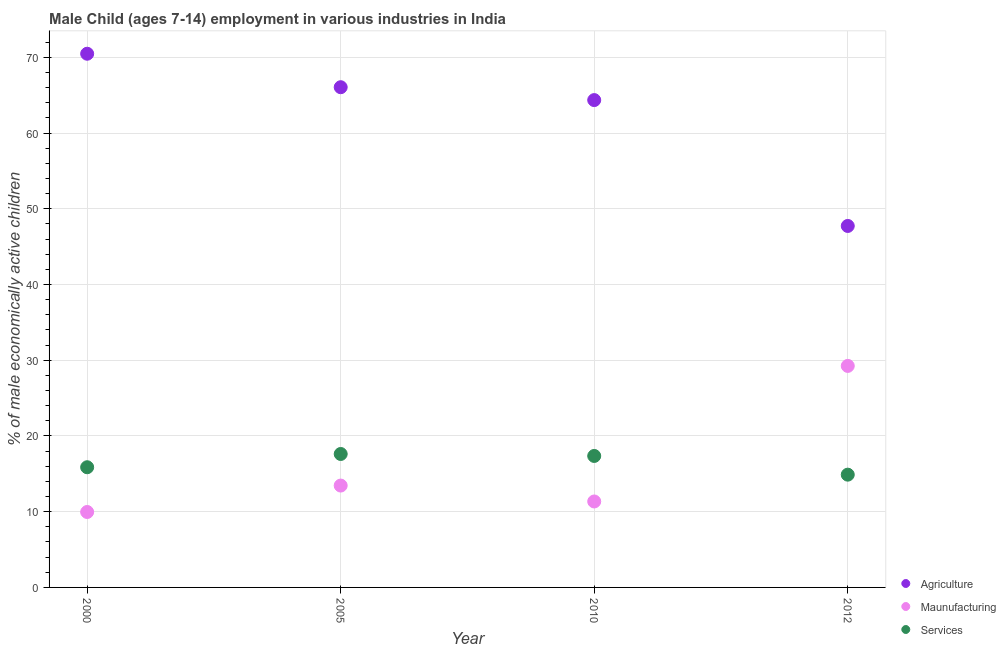How many different coloured dotlines are there?
Provide a succinct answer. 3. What is the percentage of economically active children in manufacturing in 2012?
Offer a very short reply. 29.25. Across all years, what is the maximum percentage of economically active children in services?
Keep it short and to the point. 17.62. Across all years, what is the minimum percentage of economically active children in services?
Offer a terse response. 14.89. What is the total percentage of economically active children in agriculture in the graph?
Make the answer very short. 248.6. What is the difference between the percentage of economically active children in services in 2010 and that in 2012?
Give a very brief answer. 2.47. What is the difference between the percentage of economically active children in agriculture in 2010 and the percentage of economically active children in services in 2000?
Give a very brief answer. 48.48. What is the average percentage of economically active children in manufacturing per year?
Offer a very short reply. 16. In the year 2012, what is the difference between the percentage of economically active children in services and percentage of economically active children in manufacturing?
Your answer should be compact. -14.36. In how many years, is the percentage of economically active children in services greater than 22 %?
Your response must be concise. 0. What is the ratio of the percentage of economically active children in services in 2000 to that in 2010?
Your response must be concise. 0.91. Is the percentage of economically active children in agriculture in 2005 less than that in 2012?
Your response must be concise. No. What is the difference between the highest and the second highest percentage of economically active children in services?
Offer a terse response. 0.26. What is the difference between the highest and the lowest percentage of economically active children in agriculture?
Keep it short and to the point. 22.74. In how many years, is the percentage of economically active children in services greater than the average percentage of economically active children in services taken over all years?
Keep it short and to the point. 2. Is it the case that in every year, the sum of the percentage of economically active children in agriculture and percentage of economically active children in manufacturing is greater than the percentage of economically active children in services?
Your answer should be compact. Yes. Is the percentage of economically active children in services strictly greater than the percentage of economically active children in agriculture over the years?
Provide a short and direct response. No. How many dotlines are there?
Give a very brief answer. 3. How many years are there in the graph?
Make the answer very short. 4. Are the values on the major ticks of Y-axis written in scientific E-notation?
Offer a terse response. No. Does the graph contain grids?
Your response must be concise. Yes. Where does the legend appear in the graph?
Offer a terse response. Bottom right. How many legend labels are there?
Offer a very short reply. 3. How are the legend labels stacked?
Your answer should be very brief. Vertical. What is the title of the graph?
Give a very brief answer. Male Child (ages 7-14) employment in various industries in India. Does "Taxes on income" appear as one of the legend labels in the graph?
Your response must be concise. No. What is the label or title of the Y-axis?
Your answer should be compact. % of male economically active children. What is the % of male economically active children in Agriculture in 2000?
Give a very brief answer. 70.47. What is the % of male economically active children in Maunufacturing in 2000?
Provide a short and direct response. 9.96. What is the % of male economically active children of Services in 2000?
Your answer should be compact. 15.87. What is the % of male economically active children in Agriculture in 2005?
Your response must be concise. 66.05. What is the % of male economically active children in Maunufacturing in 2005?
Your response must be concise. 13.45. What is the % of male economically active children of Services in 2005?
Your answer should be very brief. 17.62. What is the % of male economically active children of Agriculture in 2010?
Your response must be concise. 64.35. What is the % of male economically active children of Maunufacturing in 2010?
Give a very brief answer. 11.35. What is the % of male economically active children in Services in 2010?
Offer a terse response. 17.36. What is the % of male economically active children in Agriculture in 2012?
Offer a terse response. 47.73. What is the % of male economically active children in Maunufacturing in 2012?
Provide a succinct answer. 29.25. What is the % of male economically active children of Services in 2012?
Your response must be concise. 14.89. Across all years, what is the maximum % of male economically active children of Agriculture?
Offer a very short reply. 70.47. Across all years, what is the maximum % of male economically active children of Maunufacturing?
Offer a very short reply. 29.25. Across all years, what is the maximum % of male economically active children in Services?
Provide a short and direct response. 17.62. Across all years, what is the minimum % of male economically active children of Agriculture?
Give a very brief answer. 47.73. Across all years, what is the minimum % of male economically active children of Maunufacturing?
Give a very brief answer. 9.96. Across all years, what is the minimum % of male economically active children of Services?
Make the answer very short. 14.89. What is the total % of male economically active children of Agriculture in the graph?
Offer a very short reply. 248.6. What is the total % of male economically active children in Maunufacturing in the graph?
Your answer should be very brief. 64.01. What is the total % of male economically active children of Services in the graph?
Your answer should be very brief. 65.74. What is the difference between the % of male economically active children of Agriculture in 2000 and that in 2005?
Your response must be concise. 4.42. What is the difference between the % of male economically active children in Maunufacturing in 2000 and that in 2005?
Your response must be concise. -3.49. What is the difference between the % of male economically active children of Services in 2000 and that in 2005?
Make the answer very short. -1.75. What is the difference between the % of male economically active children in Agriculture in 2000 and that in 2010?
Your answer should be very brief. 6.12. What is the difference between the % of male economically active children in Maunufacturing in 2000 and that in 2010?
Your response must be concise. -1.39. What is the difference between the % of male economically active children in Services in 2000 and that in 2010?
Provide a succinct answer. -1.49. What is the difference between the % of male economically active children of Agriculture in 2000 and that in 2012?
Your answer should be compact. 22.74. What is the difference between the % of male economically active children of Maunufacturing in 2000 and that in 2012?
Provide a short and direct response. -19.29. What is the difference between the % of male economically active children in Agriculture in 2005 and that in 2010?
Your answer should be very brief. 1.7. What is the difference between the % of male economically active children in Services in 2005 and that in 2010?
Make the answer very short. 0.26. What is the difference between the % of male economically active children of Agriculture in 2005 and that in 2012?
Your response must be concise. 18.32. What is the difference between the % of male economically active children of Maunufacturing in 2005 and that in 2012?
Offer a very short reply. -15.8. What is the difference between the % of male economically active children of Services in 2005 and that in 2012?
Provide a succinct answer. 2.73. What is the difference between the % of male economically active children in Agriculture in 2010 and that in 2012?
Ensure brevity in your answer.  16.62. What is the difference between the % of male economically active children of Maunufacturing in 2010 and that in 2012?
Give a very brief answer. -17.9. What is the difference between the % of male economically active children of Services in 2010 and that in 2012?
Your answer should be very brief. 2.47. What is the difference between the % of male economically active children in Agriculture in 2000 and the % of male economically active children in Maunufacturing in 2005?
Offer a terse response. 57.02. What is the difference between the % of male economically active children in Agriculture in 2000 and the % of male economically active children in Services in 2005?
Keep it short and to the point. 52.85. What is the difference between the % of male economically active children of Maunufacturing in 2000 and the % of male economically active children of Services in 2005?
Make the answer very short. -7.66. What is the difference between the % of male economically active children in Agriculture in 2000 and the % of male economically active children in Maunufacturing in 2010?
Provide a succinct answer. 59.12. What is the difference between the % of male economically active children in Agriculture in 2000 and the % of male economically active children in Services in 2010?
Offer a terse response. 53.11. What is the difference between the % of male economically active children in Agriculture in 2000 and the % of male economically active children in Maunufacturing in 2012?
Keep it short and to the point. 41.22. What is the difference between the % of male economically active children of Agriculture in 2000 and the % of male economically active children of Services in 2012?
Your answer should be very brief. 55.58. What is the difference between the % of male economically active children of Maunufacturing in 2000 and the % of male economically active children of Services in 2012?
Give a very brief answer. -4.93. What is the difference between the % of male economically active children in Agriculture in 2005 and the % of male economically active children in Maunufacturing in 2010?
Give a very brief answer. 54.7. What is the difference between the % of male economically active children in Agriculture in 2005 and the % of male economically active children in Services in 2010?
Your answer should be very brief. 48.69. What is the difference between the % of male economically active children in Maunufacturing in 2005 and the % of male economically active children in Services in 2010?
Your response must be concise. -3.91. What is the difference between the % of male economically active children of Agriculture in 2005 and the % of male economically active children of Maunufacturing in 2012?
Provide a succinct answer. 36.8. What is the difference between the % of male economically active children in Agriculture in 2005 and the % of male economically active children in Services in 2012?
Make the answer very short. 51.16. What is the difference between the % of male economically active children of Maunufacturing in 2005 and the % of male economically active children of Services in 2012?
Make the answer very short. -1.44. What is the difference between the % of male economically active children of Agriculture in 2010 and the % of male economically active children of Maunufacturing in 2012?
Keep it short and to the point. 35.1. What is the difference between the % of male economically active children of Agriculture in 2010 and the % of male economically active children of Services in 2012?
Give a very brief answer. 49.46. What is the difference between the % of male economically active children in Maunufacturing in 2010 and the % of male economically active children in Services in 2012?
Provide a succinct answer. -3.54. What is the average % of male economically active children of Agriculture per year?
Make the answer very short. 62.15. What is the average % of male economically active children in Maunufacturing per year?
Offer a very short reply. 16. What is the average % of male economically active children in Services per year?
Your answer should be compact. 16.43. In the year 2000, what is the difference between the % of male economically active children of Agriculture and % of male economically active children of Maunufacturing?
Provide a succinct answer. 60.51. In the year 2000, what is the difference between the % of male economically active children in Agriculture and % of male economically active children in Services?
Provide a short and direct response. 54.6. In the year 2000, what is the difference between the % of male economically active children in Maunufacturing and % of male economically active children in Services?
Make the answer very short. -5.91. In the year 2005, what is the difference between the % of male economically active children of Agriculture and % of male economically active children of Maunufacturing?
Make the answer very short. 52.6. In the year 2005, what is the difference between the % of male economically active children in Agriculture and % of male economically active children in Services?
Offer a very short reply. 48.43. In the year 2005, what is the difference between the % of male economically active children in Maunufacturing and % of male economically active children in Services?
Give a very brief answer. -4.17. In the year 2010, what is the difference between the % of male economically active children in Agriculture and % of male economically active children in Maunufacturing?
Give a very brief answer. 53. In the year 2010, what is the difference between the % of male economically active children in Agriculture and % of male economically active children in Services?
Give a very brief answer. 46.99. In the year 2010, what is the difference between the % of male economically active children of Maunufacturing and % of male economically active children of Services?
Provide a succinct answer. -6.01. In the year 2012, what is the difference between the % of male economically active children in Agriculture and % of male economically active children in Maunufacturing?
Offer a terse response. 18.48. In the year 2012, what is the difference between the % of male economically active children in Agriculture and % of male economically active children in Services?
Give a very brief answer. 32.84. In the year 2012, what is the difference between the % of male economically active children in Maunufacturing and % of male economically active children in Services?
Your answer should be very brief. 14.36. What is the ratio of the % of male economically active children in Agriculture in 2000 to that in 2005?
Provide a short and direct response. 1.07. What is the ratio of the % of male economically active children in Maunufacturing in 2000 to that in 2005?
Provide a short and direct response. 0.74. What is the ratio of the % of male economically active children of Services in 2000 to that in 2005?
Provide a short and direct response. 0.9. What is the ratio of the % of male economically active children of Agriculture in 2000 to that in 2010?
Ensure brevity in your answer.  1.1. What is the ratio of the % of male economically active children of Maunufacturing in 2000 to that in 2010?
Provide a short and direct response. 0.88. What is the ratio of the % of male economically active children of Services in 2000 to that in 2010?
Provide a short and direct response. 0.91. What is the ratio of the % of male economically active children in Agriculture in 2000 to that in 2012?
Provide a succinct answer. 1.48. What is the ratio of the % of male economically active children of Maunufacturing in 2000 to that in 2012?
Your response must be concise. 0.34. What is the ratio of the % of male economically active children in Services in 2000 to that in 2012?
Your answer should be compact. 1.07. What is the ratio of the % of male economically active children of Agriculture in 2005 to that in 2010?
Your response must be concise. 1.03. What is the ratio of the % of male economically active children of Maunufacturing in 2005 to that in 2010?
Your answer should be compact. 1.19. What is the ratio of the % of male economically active children of Agriculture in 2005 to that in 2012?
Your answer should be compact. 1.38. What is the ratio of the % of male economically active children of Maunufacturing in 2005 to that in 2012?
Your response must be concise. 0.46. What is the ratio of the % of male economically active children in Services in 2005 to that in 2012?
Offer a very short reply. 1.18. What is the ratio of the % of male economically active children in Agriculture in 2010 to that in 2012?
Keep it short and to the point. 1.35. What is the ratio of the % of male economically active children in Maunufacturing in 2010 to that in 2012?
Keep it short and to the point. 0.39. What is the ratio of the % of male economically active children of Services in 2010 to that in 2012?
Your answer should be compact. 1.17. What is the difference between the highest and the second highest % of male economically active children of Agriculture?
Offer a very short reply. 4.42. What is the difference between the highest and the second highest % of male economically active children of Services?
Keep it short and to the point. 0.26. What is the difference between the highest and the lowest % of male economically active children of Agriculture?
Provide a short and direct response. 22.74. What is the difference between the highest and the lowest % of male economically active children of Maunufacturing?
Ensure brevity in your answer.  19.29. What is the difference between the highest and the lowest % of male economically active children in Services?
Offer a terse response. 2.73. 